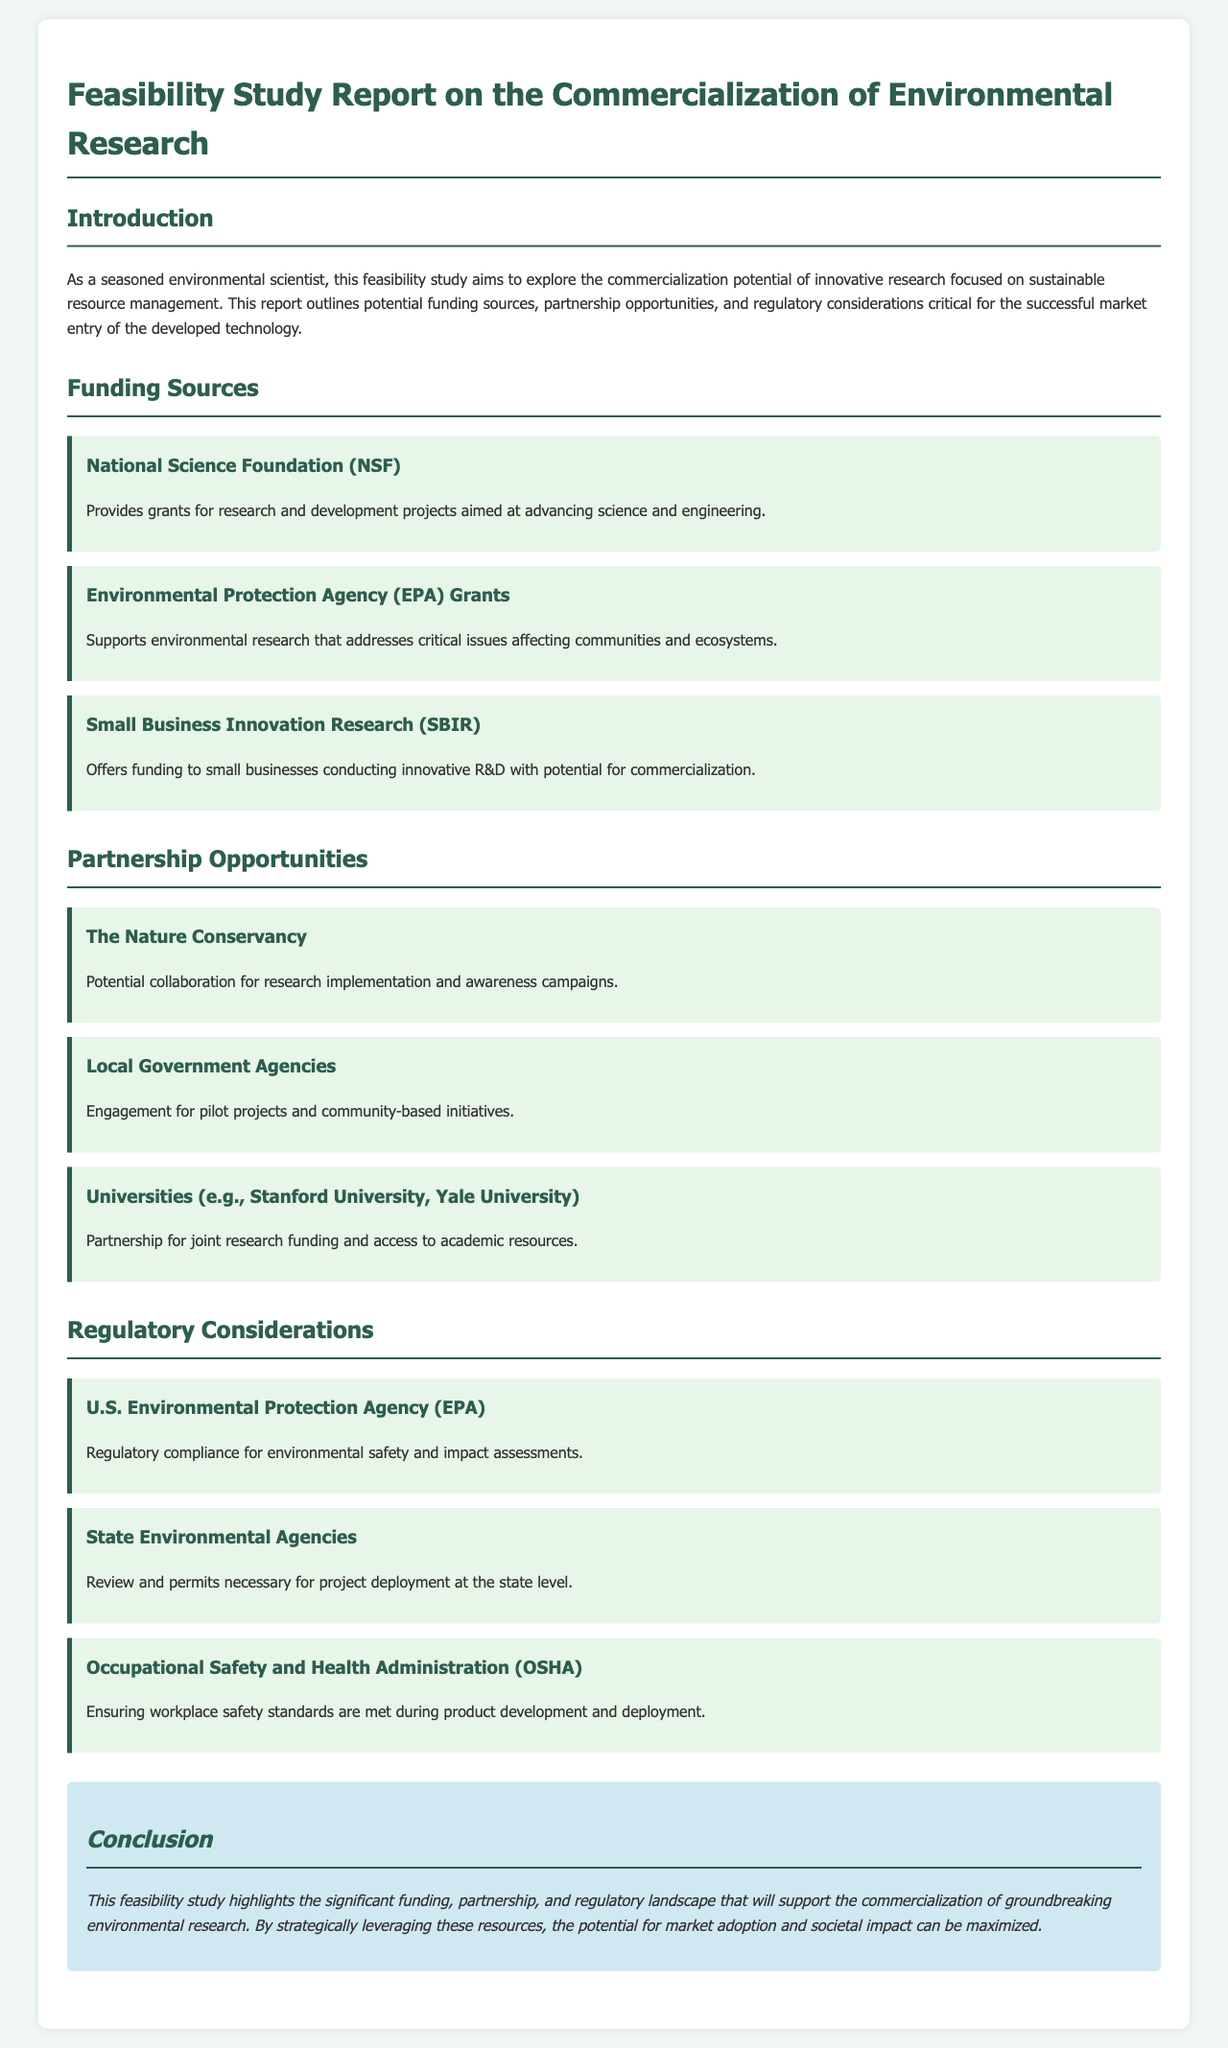What is the title of the report? The title of the report is found at the top of the document.
Answer: Feasibility Study Report on the Commercialization of Environmental Research Who provides grants for research and development projects? The National Science Foundation is mentioned as a source of grants for research and development projects.
Answer: National Science Foundation (NSF) Which organization offers funding to small businesses conducting innovative R&D? The document states that the Small Business Innovation Research program offers funding for this purpose.
Answer: Small Business Innovation Research (SBIR) What is one potential partnership opportunity outlined in the report? The report lists potential partnership opportunities including various organizations.
Answer: The Nature Conservancy Which regulatory body is mentioned as ensuring workplace safety standards? The Occupational Safety and Health Administration is mentioned in the regulatory considerations section.
Answer: Occupational Safety and Health Administration (OSHA) What type of study is discussed in the report? The document focuses on a specific type of study related to commercialization.
Answer: Feasibility study What is the primary focus of the research outlined in the report? The focus of the research pertains to sustainable resource management as indicated in the introduction.
Answer: Sustainable resource management What is the conclusion regarding the commercial potential of the research? The conclusion summarizes the findings and outlook for market adoption and societal impact.
Answer: Significant funding, partnership, and regulatory landscape How many funding sources are listed in the report? The document outlines three specific funding sources under the funding section.
Answer: Three 